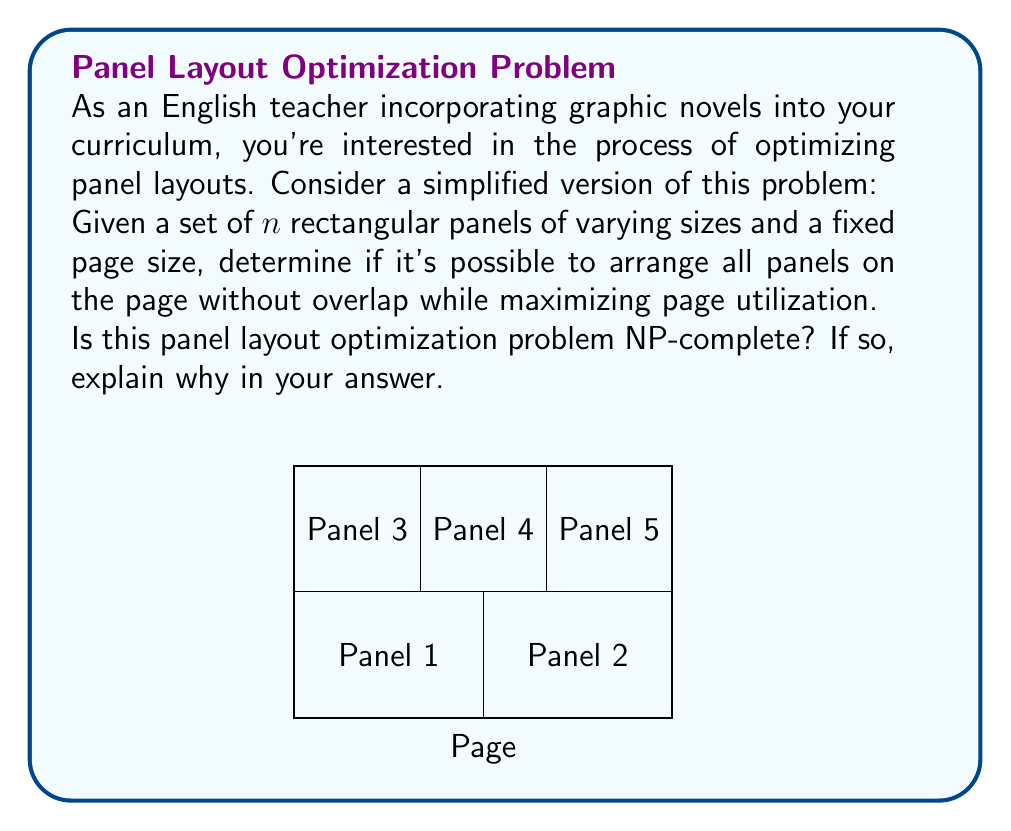Give your solution to this math problem. To determine if the panel layout optimization problem is NP-complete, we need to consider two aspects:

1. Is it in NP?
2. Is it NP-hard?

Step 1: Showing the problem is in NP
- A problem is in NP if a proposed solution can be verified in polynomial time.
- For our panel layout problem, given a specific arrangement of panels, we can easily check if all panels fit within the page and if there's no overlap in polynomial time.
- Therefore, the problem is in NP.

Step 2: Showing the problem is NP-hard
- We can prove this by reducing a known NP-complete problem to our panel layout problem.
- The perfect candidate for this is the bin packing problem, which is known to be NP-complete.

Reduction from Bin Packing to Panel Layout:
- In bin packing, we have a set of items with different sizes and bins of fixed capacity. The goal is to pack all items using the minimum number of bins.
- We can map this to our panel layout problem as follows:
  * Each item in bin packing becomes a panel in our problem.
  * Each bin becomes a page in our graphic novel.
  * The bin capacity becomes the page size.

- If we could solve the panel layout problem efficiently, we could use it to solve bin packing:
  1. Start with one page (bin).
  2. Try to fit all panels (items) on the page.
  3. If successful, we've found the optimal solution for bin packing.
  4. If not, add another page and repeat until successful.

- This reduction shows that our panel layout problem is at least as hard as bin packing.

Conclusion:
- Since the problem is in NP and is NP-hard (by reduction from bin packing), it is NP-complete.
Answer: Yes, NP-complete. 